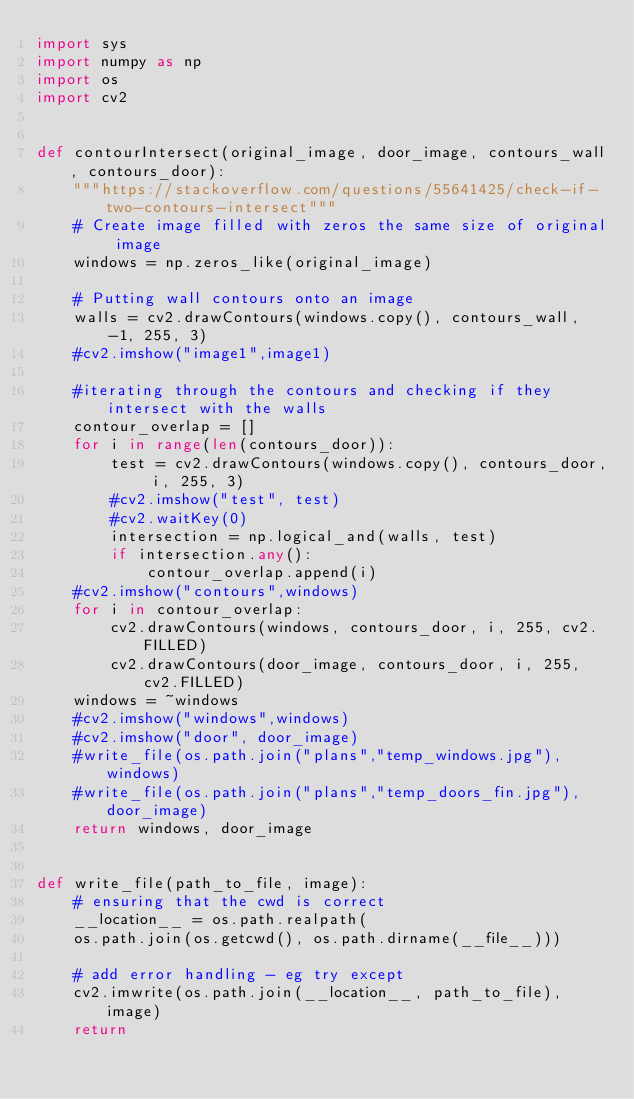Convert code to text. <code><loc_0><loc_0><loc_500><loc_500><_Python_>import sys
import numpy as np
import os
import cv2


def contourIntersect(original_image, door_image, contours_wall, contours_door):
    """https://stackoverflow.com/questions/55641425/check-if-two-contours-intersect"""
    # Create image filled with zeros the same size of original image
    windows = np.zeros_like(original_image)

    # Putting wall contours onto an image
    walls = cv2.drawContours(windows.copy(), contours_wall, -1, 255, 3)
    #cv2.imshow("image1",image1)

    #iterating through the contours and checking if they intersect with the walls
    contour_overlap = []
    for i in range(len(contours_door)):
        test = cv2.drawContours(windows.copy(), contours_door, i, 255, 3)
        #cv2.imshow("test", test)
        #cv2.waitKey(0)
        intersection = np.logical_and(walls, test)
        if intersection.any():
            contour_overlap.append(i)
    #cv2.imshow("contours",windows)
    for i in contour_overlap:
        cv2.drawContours(windows, contours_door, i, 255, cv2.FILLED)
        cv2.drawContours(door_image, contours_door, i, 255, cv2.FILLED)
    windows = ~windows
    #cv2.imshow("windows",windows)
    #cv2.imshow("door", door_image)
    #write_file(os.path.join("plans","temp_windows.jpg"), windows)
    #write_file(os.path.join("plans","temp_doors_fin.jpg"), door_image)
    return windows, door_image


def write_file(path_to_file, image):
    # ensuring that the cwd is correct
    __location__ = os.path.realpath(
    os.path.join(os.getcwd(), os.path.dirname(__file__)))

    # add error handling - eg try except
    cv2.imwrite(os.path.join(__location__, path_to_file), image)
    return

</code> 